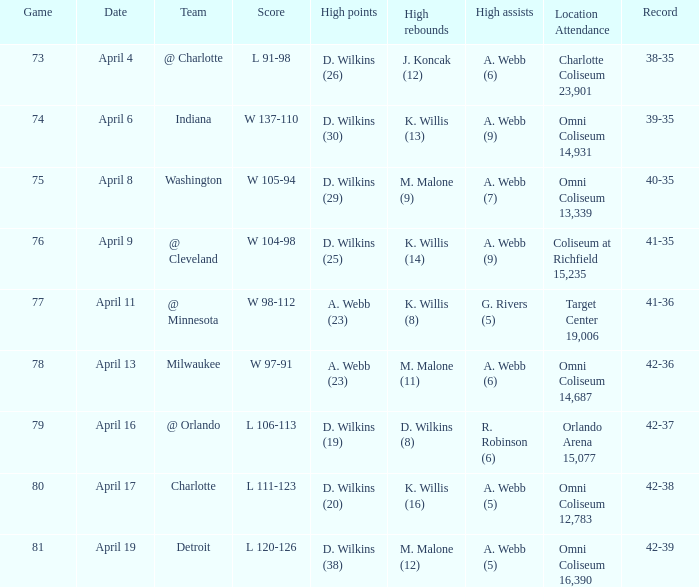Where was the location and attendance when they played milwaukee? Omni Coliseum 14,687. 